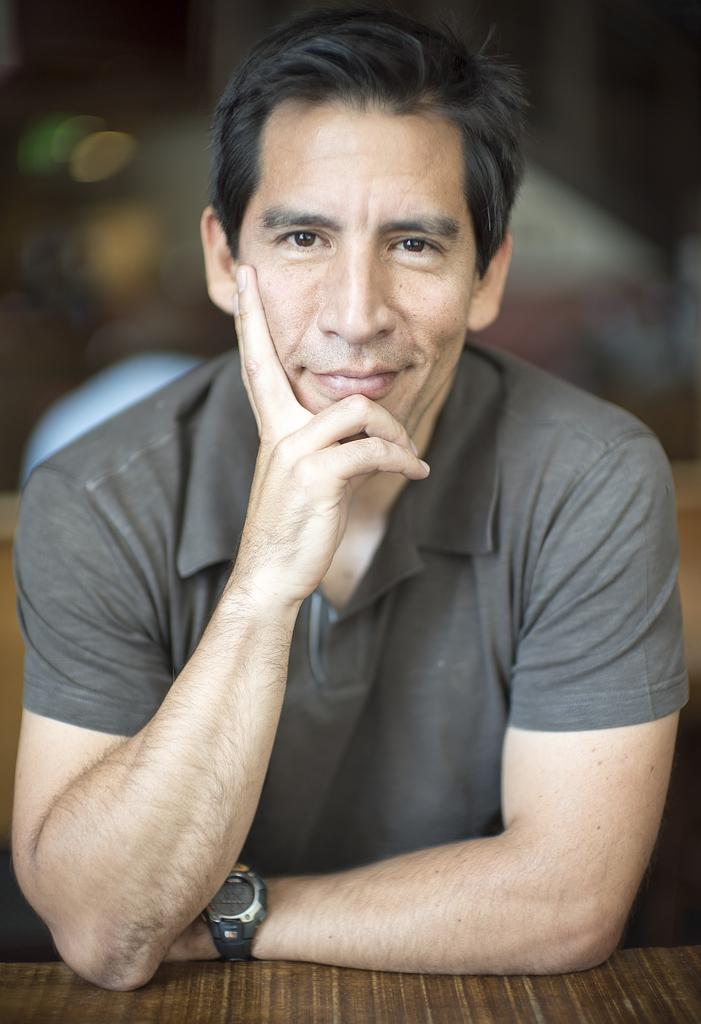Who is present in the image? There is a man in the image. What is the man doing in the image? The man is smiling in the image. What object can be seen in the image besides the man? There is a table in the image. Can you describe the background of the image? The background of the image is blurred. What type of cake is mom holding in the image? There is no mom or cake present in the image; it features a man smiling and a table. How many cakes are visible in the image? There are no cakes visible in the image; only a man, a table, and a blurred background are present. 